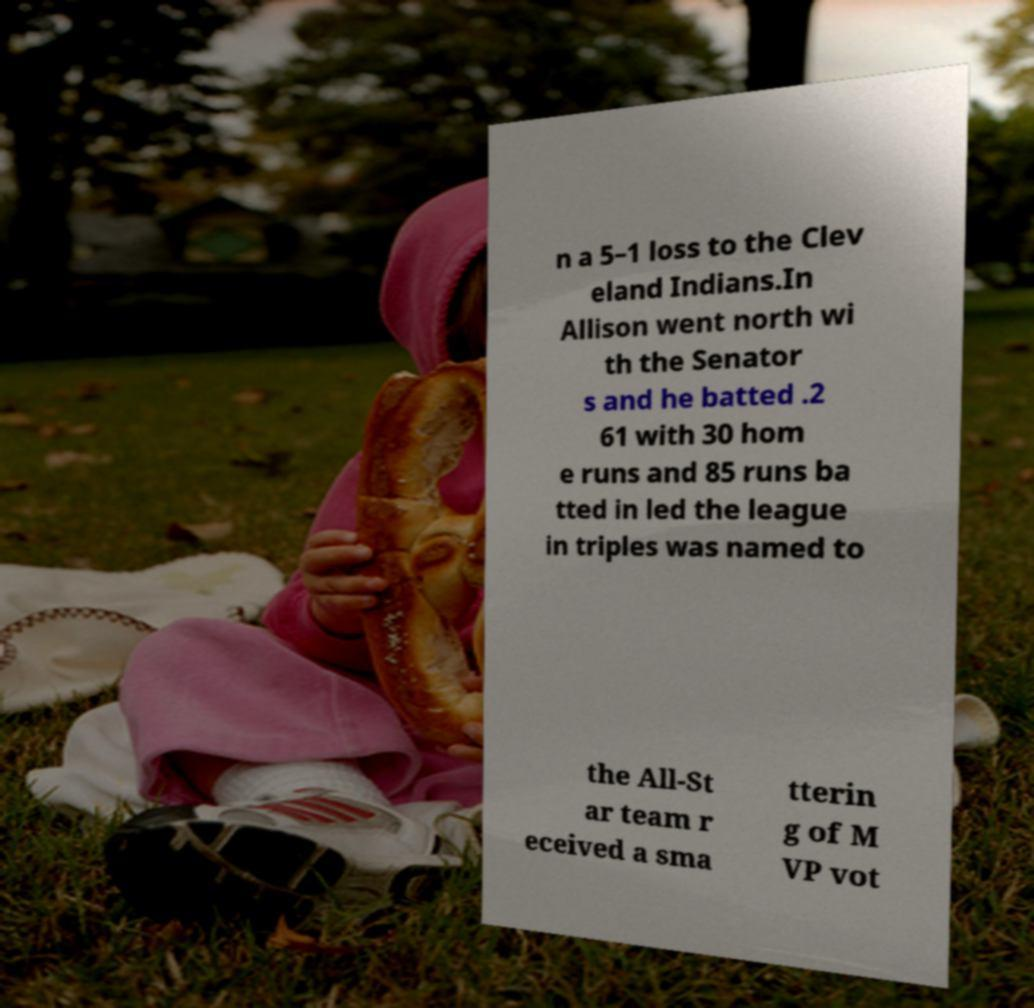What messages or text are displayed in this image? I need them in a readable, typed format. n a 5–1 loss to the Clev eland Indians.In Allison went north wi th the Senator s and he batted .2 61 with 30 hom e runs and 85 runs ba tted in led the league in triples was named to the All-St ar team r eceived a sma tterin g of M VP vot 